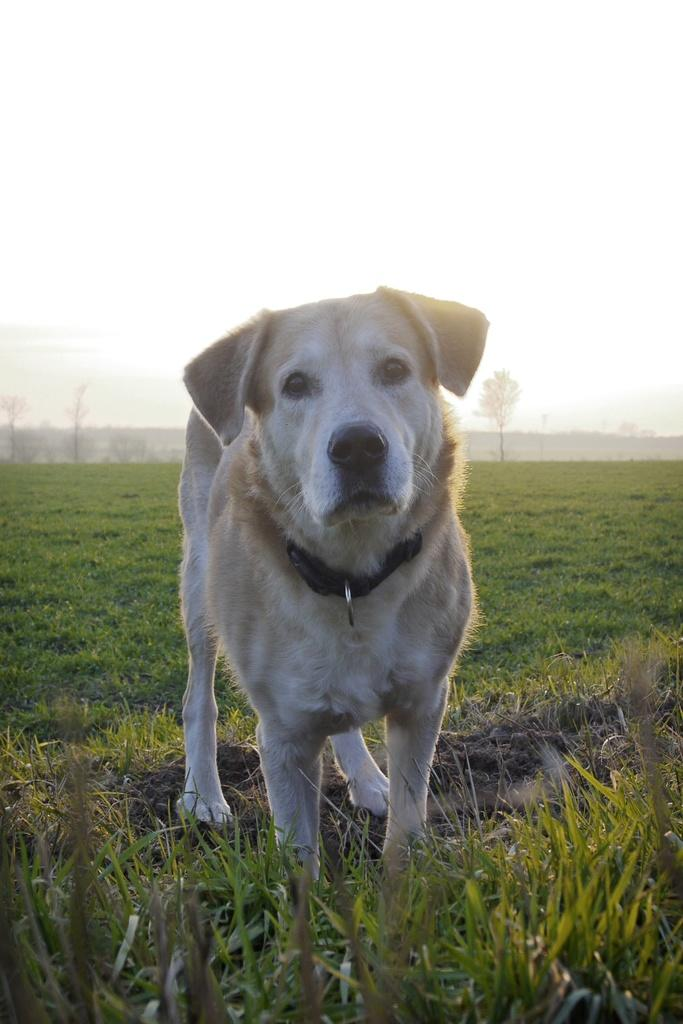What type of outdoor space is shown in the image? There is a garden in the image. What animal can be seen in the garden? There is a dog in the image, standing in a pose. What type of vegetation is visible in the image? There are trees visible in the image. What type of grain is being harvested in the garden during the summer season? There is no grain being harvested in the garden, nor is there any indication of the season being summer in the image. 